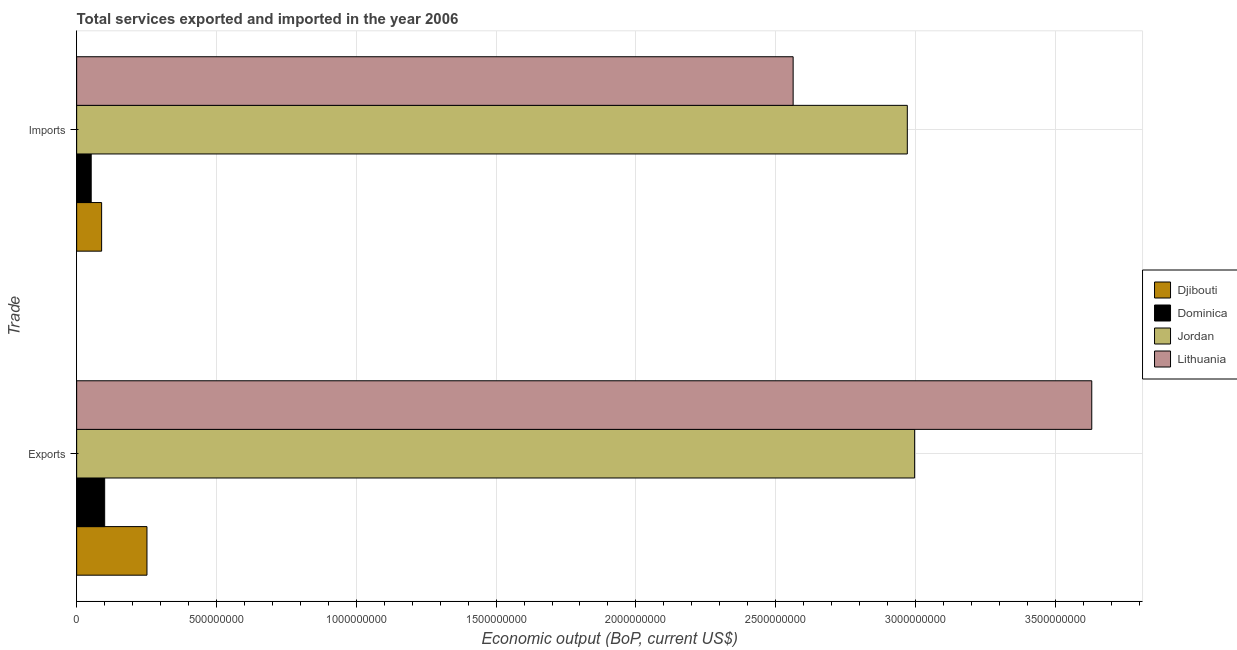What is the label of the 2nd group of bars from the top?
Keep it short and to the point. Exports. What is the amount of service exports in Djibouti?
Give a very brief answer. 2.51e+08. Across all countries, what is the maximum amount of service exports?
Provide a succinct answer. 3.63e+09. Across all countries, what is the minimum amount of service exports?
Your answer should be compact. 1.00e+08. In which country was the amount of service exports maximum?
Make the answer very short. Lithuania. In which country was the amount of service exports minimum?
Offer a very short reply. Dominica. What is the total amount of service imports in the graph?
Your answer should be very brief. 5.67e+09. What is the difference between the amount of service imports in Dominica and that in Jordan?
Offer a terse response. -2.92e+09. What is the difference between the amount of service imports in Dominica and the amount of service exports in Lithuania?
Your answer should be very brief. -3.58e+09. What is the average amount of service exports per country?
Your answer should be compact. 1.74e+09. What is the difference between the amount of service imports and amount of service exports in Dominica?
Your answer should be compact. -4.82e+07. What is the ratio of the amount of service exports in Dominica to that in Lithuania?
Your response must be concise. 0.03. Is the amount of service imports in Jordan less than that in Djibouti?
Your response must be concise. No. In how many countries, is the amount of service exports greater than the average amount of service exports taken over all countries?
Give a very brief answer. 2. What does the 1st bar from the top in Imports represents?
Your answer should be compact. Lithuania. What does the 3rd bar from the bottom in Exports represents?
Provide a succinct answer. Jordan. How many bars are there?
Your response must be concise. 8. Does the graph contain any zero values?
Your response must be concise. No. Does the graph contain grids?
Your answer should be very brief. Yes. How many legend labels are there?
Provide a short and direct response. 4. How are the legend labels stacked?
Ensure brevity in your answer.  Vertical. What is the title of the graph?
Offer a terse response. Total services exported and imported in the year 2006. Does "Bermuda" appear as one of the legend labels in the graph?
Make the answer very short. No. What is the label or title of the X-axis?
Make the answer very short. Economic output (BoP, current US$). What is the label or title of the Y-axis?
Your answer should be very brief. Trade. What is the Economic output (BoP, current US$) of Djibouti in Exports?
Your answer should be very brief. 2.51e+08. What is the Economic output (BoP, current US$) of Dominica in Exports?
Provide a succinct answer. 1.00e+08. What is the Economic output (BoP, current US$) in Jordan in Exports?
Your answer should be compact. 3.00e+09. What is the Economic output (BoP, current US$) in Lithuania in Exports?
Provide a succinct answer. 3.63e+09. What is the Economic output (BoP, current US$) of Djibouti in Imports?
Your response must be concise. 8.93e+07. What is the Economic output (BoP, current US$) in Dominica in Imports?
Your answer should be compact. 5.20e+07. What is the Economic output (BoP, current US$) of Jordan in Imports?
Offer a terse response. 2.97e+09. What is the Economic output (BoP, current US$) of Lithuania in Imports?
Offer a very short reply. 2.56e+09. Across all Trade, what is the maximum Economic output (BoP, current US$) in Djibouti?
Provide a succinct answer. 2.51e+08. Across all Trade, what is the maximum Economic output (BoP, current US$) in Dominica?
Your answer should be compact. 1.00e+08. Across all Trade, what is the maximum Economic output (BoP, current US$) of Jordan?
Offer a very short reply. 3.00e+09. Across all Trade, what is the maximum Economic output (BoP, current US$) in Lithuania?
Provide a short and direct response. 3.63e+09. Across all Trade, what is the minimum Economic output (BoP, current US$) of Djibouti?
Provide a short and direct response. 8.93e+07. Across all Trade, what is the minimum Economic output (BoP, current US$) in Dominica?
Ensure brevity in your answer.  5.20e+07. Across all Trade, what is the minimum Economic output (BoP, current US$) of Jordan?
Offer a very short reply. 2.97e+09. Across all Trade, what is the minimum Economic output (BoP, current US$) of Lithuania?
Make the answer very short. 2.56e+09. What is the total Economic output (BoP, current US$) of Djibouti in the graph?
Your response must be concise. 3.41e+08. What is the total Economic output (BoP, current US$) of Dominica in the graph?
Ensure brevity in your answer.  1.52e+08. What is the total Economic output (BoP, current US$) in Jordan in the graph?
Your response must be concise. 5.97e+09. What is the total Economic output (BoP, current US$) in Lithuania in the graph?
Provide a short and direct response. 6.19e+09. What is the difference between the Economic output (BoP, current US$) in Djibouti in Exports and that in Imports?
Make the answer very short. 1.62e+08. What is the difference between the Economic output (BoP, current US$) in Dominica in Exports and that in Imports?
Your response must be concise. 4.82e+07. What is the difference between the Economic output (BoP, current US$) in Jordan in Exports and that in Imports?
Keep it short and to the point. 2.62e+07. What is the difference between the Economic output (BoP, current US$) of Lithuania in Exports and that in Imports?
Ensure brevity in your answer.  1.07e+09. What is the difference between the Economic output (BoP, current US$) of Djibouti in Exports and the Economic output (BoP, current US$) of Dominica in Imports?
Provide a succinct answer. 1.99e+08. What is the difference between the Economic output (BoP, current US$) of Djibouti in Exports and the Economic output (BoP, current US$) of Jordan in Imports?
Your response must be concise. -2.72e+09. What is the difference between the Economic output (BoP, current US$) in Djibouti in Exports and the Economic output (BoP, current US$) in Lithuania in Imports?
Offer a very short reply. -2.31e+09. What is the difference between the Economic output (BoP, current US$) in Dominica in Exports and the Economic output (BoP, current US$) in Jordan in Imports?
Offer a very short reply. -2.87e+09. What is the difference between the Economic output (BoP, current US$) of Dominica in Exports and the Economic output (BoP, current US$) of Lithuania in Imports?
Your answer should be very brief. -2.46e+09. What is the difference between the Economic output (BoP, current US$) in Jordan in Exports and the Economic output (BoP, current US$) in Lithuania in Imports?
Give a very brief answer. 4.35e+08. What is the average Economic output (BoP, current US$) of Djibouti per Trade?
Your answer should be compact. 1.70e+08. What is the average Economic output (BoP, current US$) in Dominica per Trade?
Offer a terse response. 7.61e+07. What is the average Economic output (BoP, current US$) in Jordan per Trade?
Ensure brevity in your answer.  2.98e+09. What is the average Economic output (BoP, current US$) of Lithuania per Trade?
Provide a short and direct response. 3.10e+09. What is the difference between the Economic output (BoP, current US$) in Djibouti and Economic output (BoP, current US$) in Dominica in Exports?
Provide a short and direct response. 1.51e+08. What is the difference between the Economic output (BoP, current US$) in Djibouti and Economic output (BoP, current US$) in Jordan in Exports?
Your response must be concise. -2.75e+09. What is the difference between the Economic output (BoP, current US$) of Djibouti and Economic output (BoP, current US$) of Lithuania in Exports?
Provide a succinct answer. -3.38e+09. What is the difference between the Economic output (BoP, current US$) of Dominica and Economic output (BoP, current US$) of Jordan in Exports?
Offer a terse response. -2.90e+09. What is the difference between the Economic output (BoP, current US$) of Dominica and Economic output (BoP, current US$) of Lithuania in Exports?
Keep it short and to the point. -3.53e+09. What is the difference between the Economic output (BoP, current US$) in Jordan and Economic output (BoP, current US$) in Lithuania in Exports?
Your response must be concise. -6.33e+08. What is the difference between the Economic output (BoP, current US$) in Djibouti and Economic output (BoP, current US$) in Dominica in Imports?
Offer a terse response. 3.73e+07. What is the difference between the Economic output (BoP, current US$) of Djibouti and Economic output (BoP, current US$) of Jordan in Imports?
Offer a terse response. -2.88e+09. What is the difference between the Economic output (BoP, current US$) of Djibouti and Economic output (BoP, current US$) of Lithuania in Imports?
Your response must be concise. -2.47e+09. What is the difference between the Economic output (BoP, current US$) of Dominica and Economic output (BoP, current US$) of Jordan in Imports?
Provide a short and direct response. -2.92e+09. What is the difference between the Economic output (BoP, current US$) of Dominica and Economic output (BoP, current US$) of Lithuania in Imports?
Offer a terse response. -2.51e+09. What is the difference between the Economic output (BoP, current US$) in Jordan and Economic output (BoP, current US$) in Lithuania in Imports?
Make the answer very short. 4.08e+08. What is the ratio of the Economic output (BoP, current US$) in Djibouti in Exports to that in Imports?
Offer a very short reply. 2.82. What is the ratio of the Economic output (BoP, current US$) of Dominica in Exports to that in Imports?
Provide a succinct answer. 1.93. What is the ratio of the Economic output (BoP, current US$) of Jordan in Exports to that in Imports?
Make the answer very short. 1.01. What is the ratio of the Economic output (BoP, current US$) in Lithuania in Exports to that in Imports?
Give a very brief answer. 1.42. What is the difference between the highest and the second highest Economic output (BoP, current US$) of Djibouti?
Your answer should be compact. 1.62e+08. What is the difference between the highest and the second highest Economic output (BoP, current US$) of Dominica?
Give a very brief answer. 4.82e+07. What is the difference between the highest and the second highest Economic output (BoP, current US$) of Jordan?
Your answer should be compact. 2.62e+07. What is the difference between the highest and the second highest Economic output (BoP, current US$) in Lithuania?
Offer a very short reply. 1.07e+09. What is the difference between the highest and the lowest Economic output (BoP, current US$) in Djibouti?
Provide a short and direct response. 1.62e+08. What is the difference between the highest and the lowest Economic output (BoP, current US$) in Dominica?
Make the answer very short. 4.82e+07. What is the difference between the highest and the lowest Economic output (BoP, current US$) of Jordan?
Your answer should be very brief. 2.62e+07. What is the difference between the highest and the lowest Economic output (BoP, current US$) in Lithuania?
Give a very brief answer. 1.07e+09. 